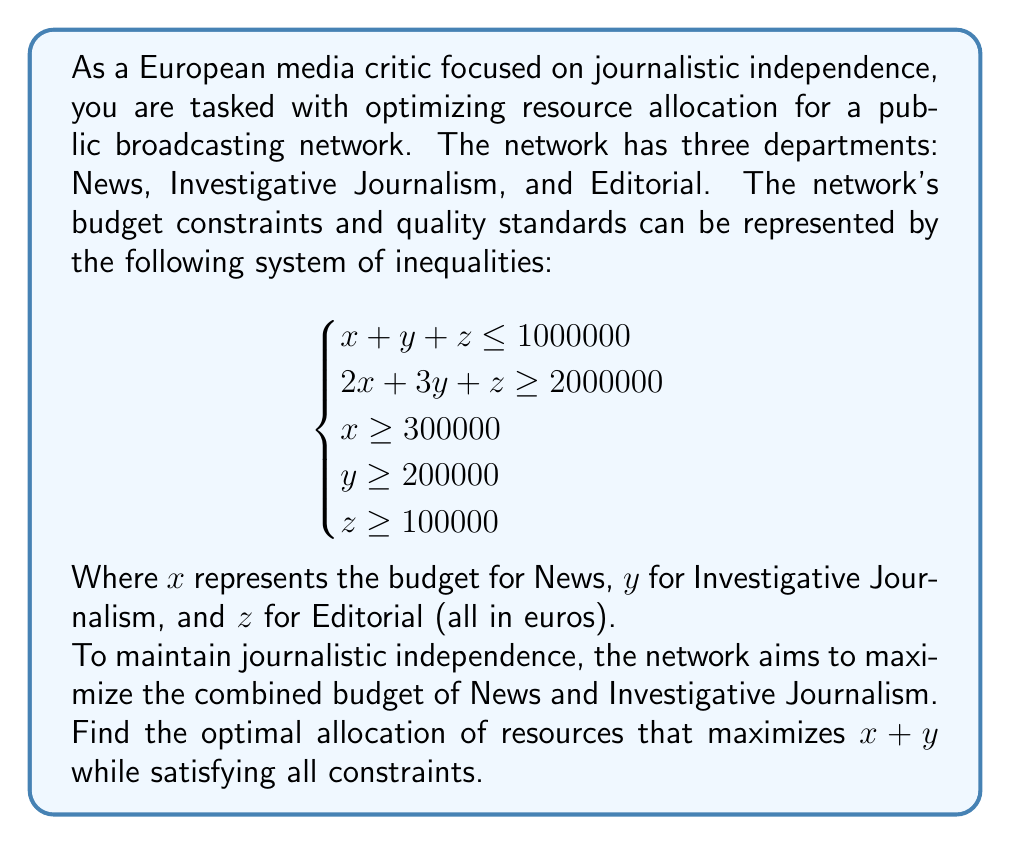Give your solution to this math problem. To solve this problem, we'll use the following steps:

1) First, we recognize that we want to maximize $x + y$ subject to the given constraints.

2) The constraint $x + y + z \leq 1000000$ will be binding at the optimal solution, as we want to use all available resources. So we can replace this with an equality:

   $x + y + z = 1000000$ ... (1)

3) We also know that the constraint $2x + 3y + z \geq 2000000$ will be binding at the optimal solution, as any surplus here could be used to increase $x$ or $y$. So:

   $2x + 3y + z = 2000000$ ... (2)

4) Subtracting equation (1) from equation (2):

   $x + 2y = 1000000$ ... (3)

5) From (1) and (3), we can express $z$ in terms of $y$:

   $z = 1000000 - x - y = 1000000 - (1000000 - 2y) - y = y$

6) So our problem reduces to maximizing $x + y$ subject to:

   $$\begin{cases}
   x + 2y = 1000000 \\
   x \geq 300000 \\
   y \geq 200000 \\
   y \geq 100000
   \end{cases}$$

7) From the first equation: $x = 1000000 - 2y$

8) Substituting this into $x \geq 300000$:

   $1000000 - 2y \geq 300000$
   $-2y \geq -700000$
   $y \leq 350000$

9) So $y$ is bounded by $200000 \leq y \leq 350000$

10) To maximize $x + y$, we want $y$ as large as possible within these bounds. So $y = 350000$

11) Then $x = 1000000 - 2(350000) = 300000$

12) And $z = y = 350000$

We can verify that this solution satisfies all original constraints.
Answer: The optimal allocation is:
News (x): €300,000
Investigative Journalism (y): €350,000
Editorial (z): €350,000

This maximizes $x + y$ at €650,000. 